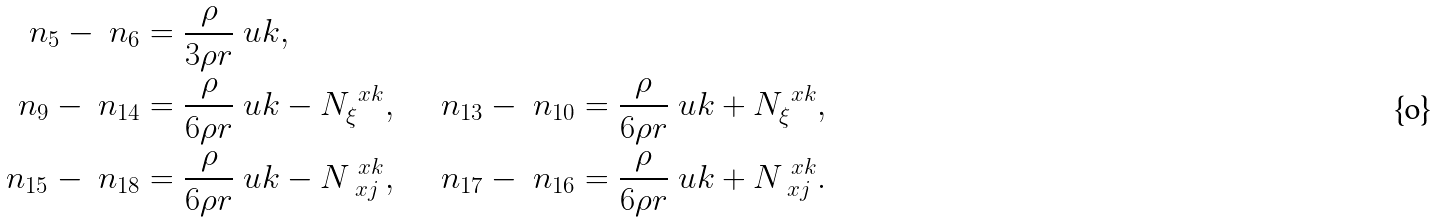<formula> <loc_0><loc_0><loc_500><loc_500>\ n _ { 5 } - \ n _ { 6 } & = \frac { \rho } { 3 \rho r } \ u k , \\ \ n _ { 9 } - \ n _ { 1 4 } & = \frac { \rho } { 6 \rho r } \ u k - N _ { \xi } ^ { \ x k } , \quad \ n _ { 1 3 } - \ n _ { 1 0 } = \frac { \rho } { 6 \rho r } \ u k + N _ { \xi } ^ { \ x k } , \\ \ n _ { 1 5 } - \ n _ { 1 8 } & = \frac { \rho } { 6 \rho r } \ u k - N _ { \ x j } ^ { \ x k } , \quad \ n _ { 1 7 } - \ n _ { 1 6 } = \frac { \rho } { 6 \rho r } \ u k + N _ { \ x j } ^ { \ x k } .</formula> 